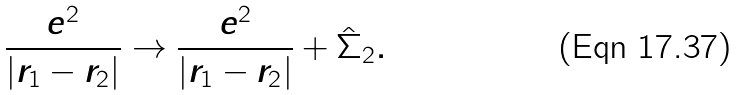Convert formula to latex. <formula><loc_0><loc_0><loc_500><loc_500>\frac { e ^ { 2 } } { | r _ { 1 } - r _ { 2 } | } \rightarrow \frac { e ^ { 2 } } { | r _ { 1 } - r _ { 2 } | } + \hat { \Sigma } _ { 2 } .</formula> 